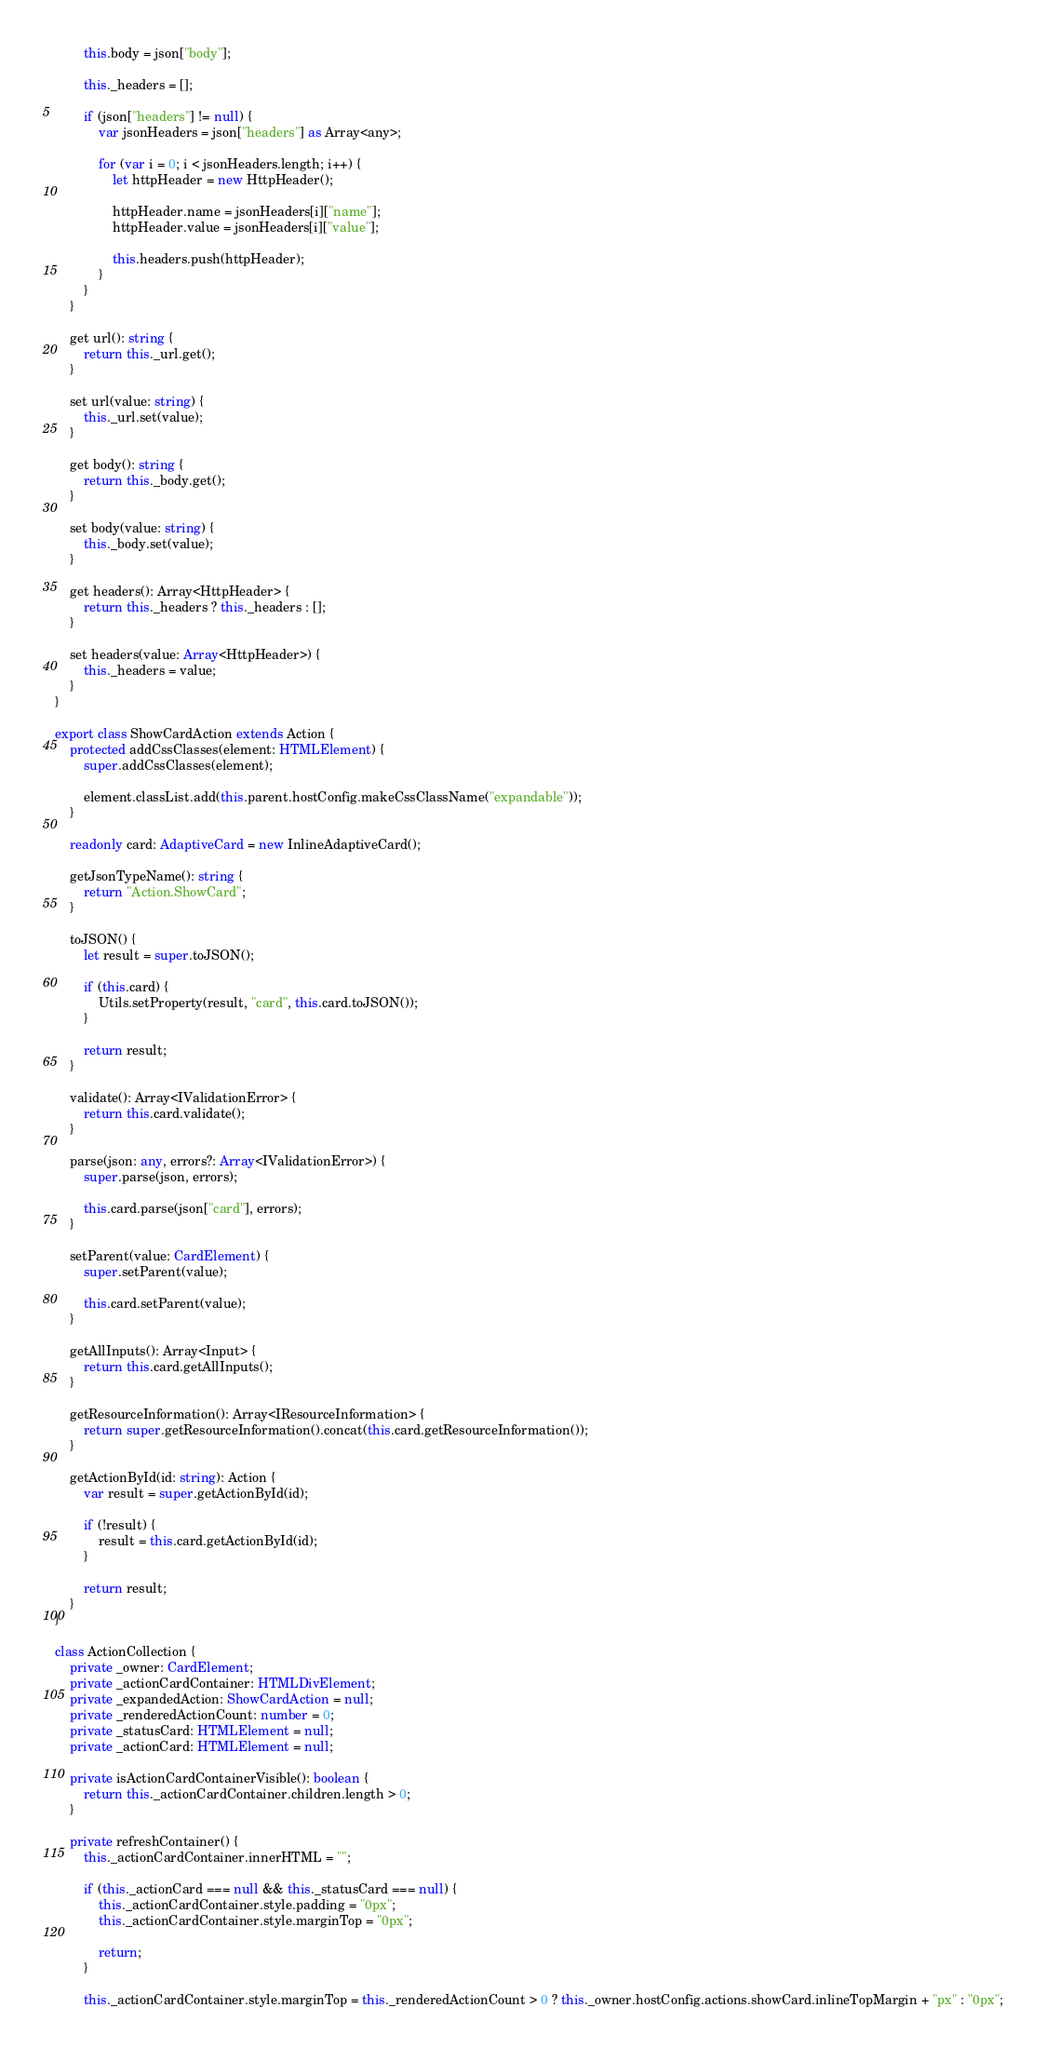Convert code to text. <code><loc_0><loc_0><loc_500><loc_500><_TypeScript_>        this.body = json["body"];

        this._headers = [];

        if (json["headers"] != null) {
            var jsonHeaders = json["headers"] as Array<any>;

            for (var i = 0; i < jsonHeaders.length; i++) {
                let httpHeader = new HttpHeader();

                httpHeader.name = jsonHeaders[i]["name"];
                httpHeader.value = jsonHeaders[i]["value"];

                this.headers.push(httpHeader);
            }
        }
    }

    get url(): string {
        return this._url.get();
    }

    set url(value: string) {
        this._url.set(value);
    }

    get body(): string {
        return this._body.get();
    }

    set body(value: string) {
        this._body.set(value);
    }

    get headers(): Array<HttpHeader> {
        return this._headers ? this._headers : [];
    }

    set headers(value: Array<HttpHeader>) {
        this._headers = value;
    }
}

export class ShowCardAction extends Action {
    protected addCssClasses(element: HTMLElement) {
        super.addCssClasses(element);

        element.classList.add(this.parent.hostConfig.makeCssClassName("expandable"));
    }

    readonly card: AdaptiveCard = new InlineAdaptiveCard();

    getJsonTypeName(): string {
        return "Action.ShowCard";
    }

    toJSON() {
        let result = super.toJSON();

        if (this.card) {
            Utils.setProperty(result, "card", this.card.toJSON());
        }

        return result;
    }

    validate(): Array<IValidationError> {
        return this.card.validate();
    }

    parse(json: any, errors?: Array<IValidationError>) {
        super.parse(json, errors);

        this.card.parse(json["card"], errors);
    }

    setParent(value: CardElement) {
        super.setParent(value);

        this.card.setParent(value);
    }

    getAllInputs(): Array<Input> {
        return this.card.getAllInputs();
    }

    getResourceInformation(): Array<IResourceInformation> {
        return super.getResourceInformation().concat(this.card.getResourceInformation());
    }

    getActionById(id: string): Action {
        var result = super.getActionById(id);

        if (!result) {
            result = this.card.getActionById(id);
        }

        return result;
    }
}

class ActionCollection {
    private _owner: CardElement;
    private _actionCardContainer: HTMLDivElement;
    private _expandedAction: ShowCardAction = null;
    private _renderedActionCount: number = 0;
    private _statusCard: HTMLElement = null;
    private _actionCard: HTMLElement = null;

    private isActionCardContainerVisible(): boolean {
        return this._actionCardContainer.children.length > 0;
    }

    private refreshContainer() {
        this._actionCardContainer.innerHTML = "";

        if (this._actionCard === null && this._statusCard === null) {
            this._actionCardContainer.style.padding = "0px";
            this._actionCardContainer.style.marginTop = "0px";

            return;
        }

        this._actionCardContainer.style.marginTop = this._renderedActionCount > 0 ? this._owner.hostConfig.actions.showCard.inlineTopMargin + "px" : "0px";
</code> 